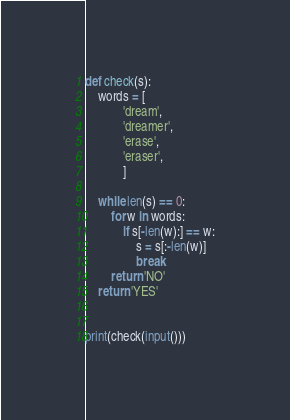Convert code to text. <code><loc_0><loc_0><loc_500><loc_500><_Python_>def check(s):
    words = [
            'dream',
            'dreamer',
            'erase',
            'eraser',
            ]

    while len(s) == 0:
        for w in words:
            if s[-len(w):] == w:
                s = s[:-len(w)]
                break
        return 'NO'
    return 'YES'


print(check(input()))
</code> 